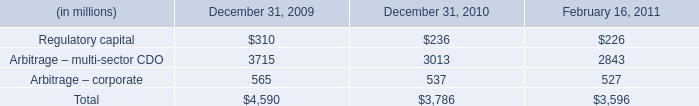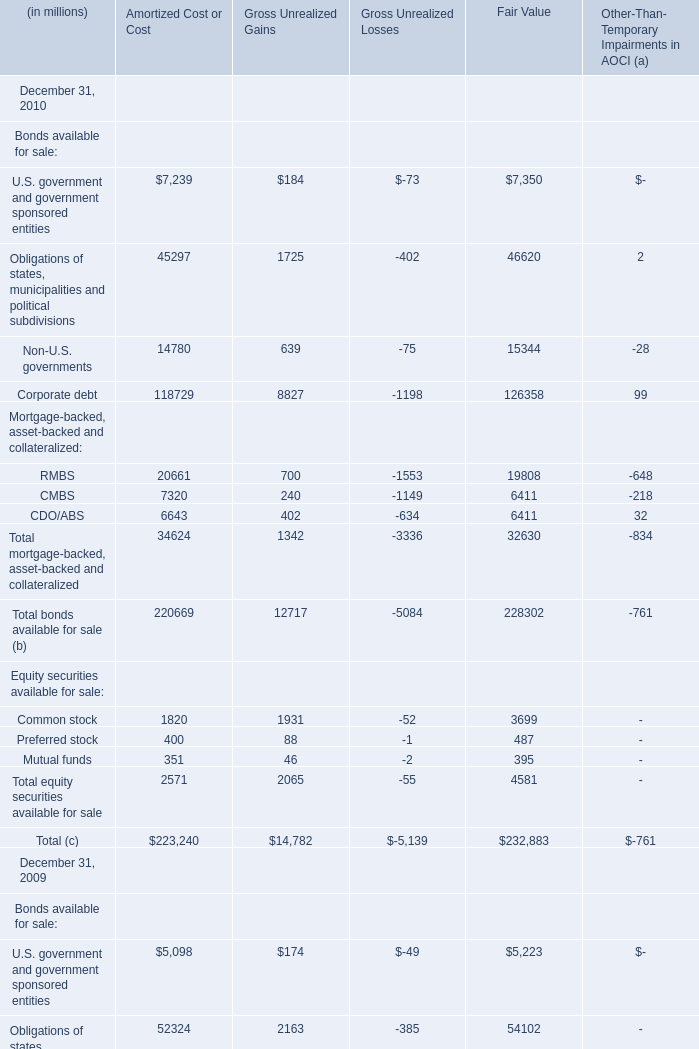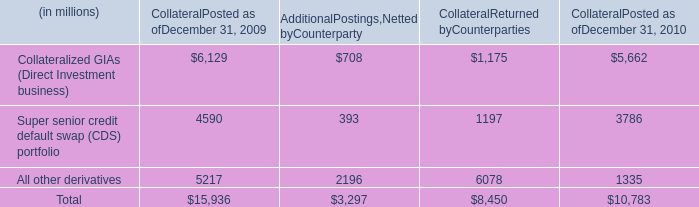What's the greatest value of Bonds available for sale of Amortized Cost or Cost in 2010? (in millions) 
Answer: 118729. 